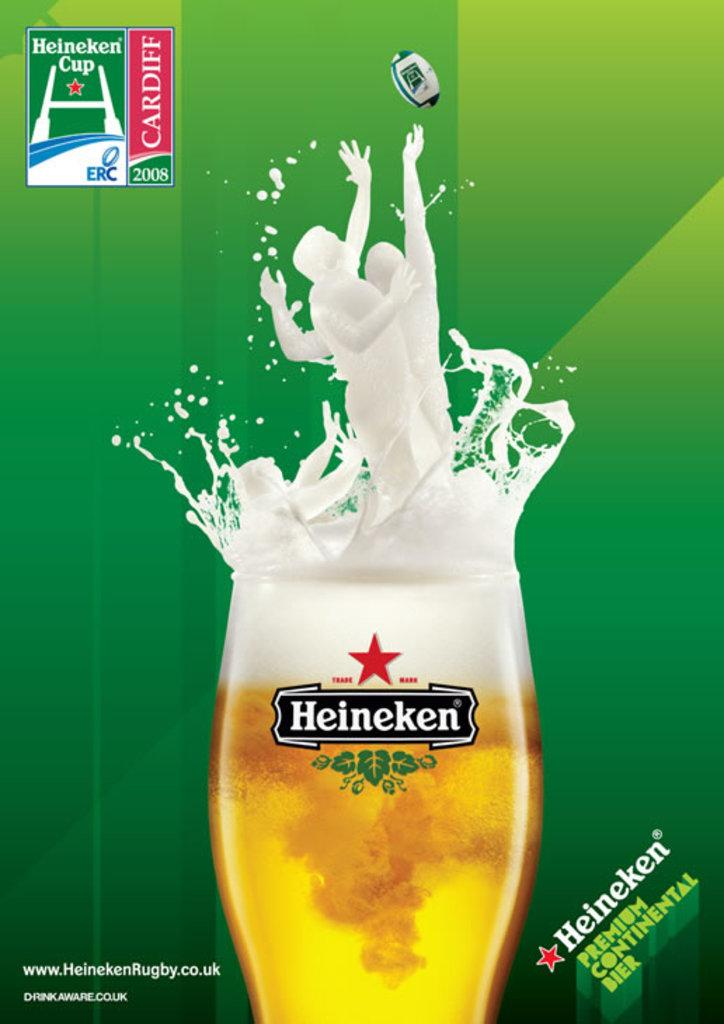<image>
Give a short and clear explanation of the subsequent image. An add for the Heineken Cup has a glass of Heineken that has players splashing out of it. 